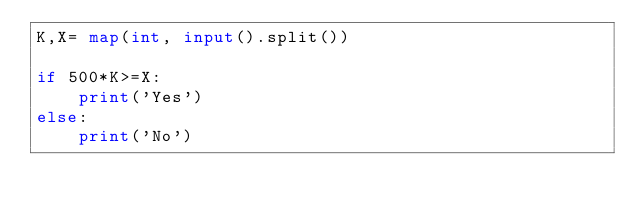Convert code to text. <code><loc_0><loc_0><loc_500><loc_500><_Python_>K,X= map(int, input().split())

if 500*K>=X:
    print('Yes')
else:
    print('No')</code> 